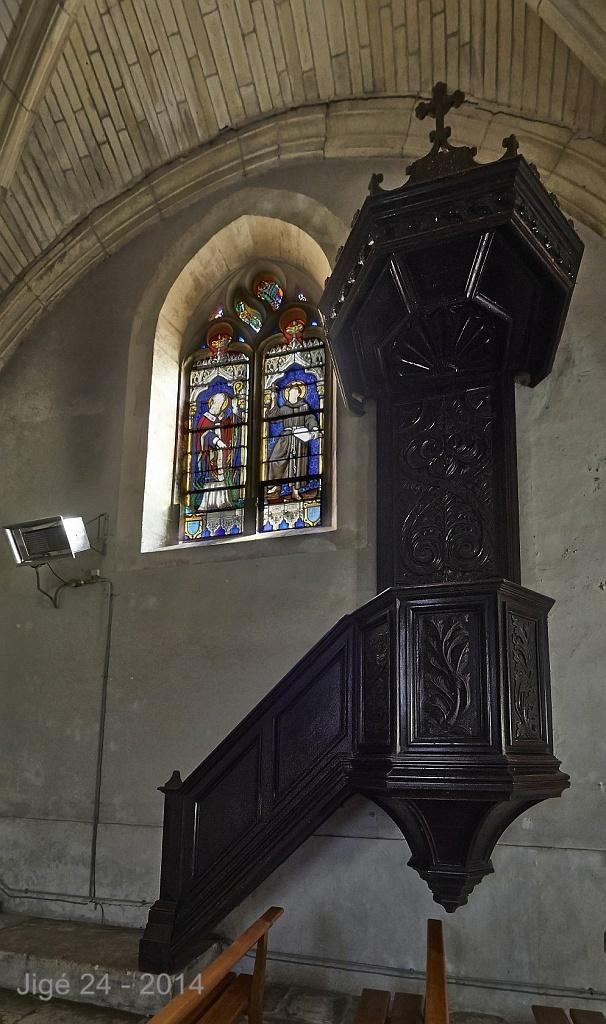What type of structure can be seen in the image? There is a wall in the image. What feature is present in the wall? There is a window in the image. What is located above the wall and window? There is a roof in the image. How many rings are visible on the wall in the image? There are no rings present in the image; it only features a wall, window, and roof. What type of army is depicted in the image? There is no army or military presence in the image; it only shows a wall, window, and roof. 